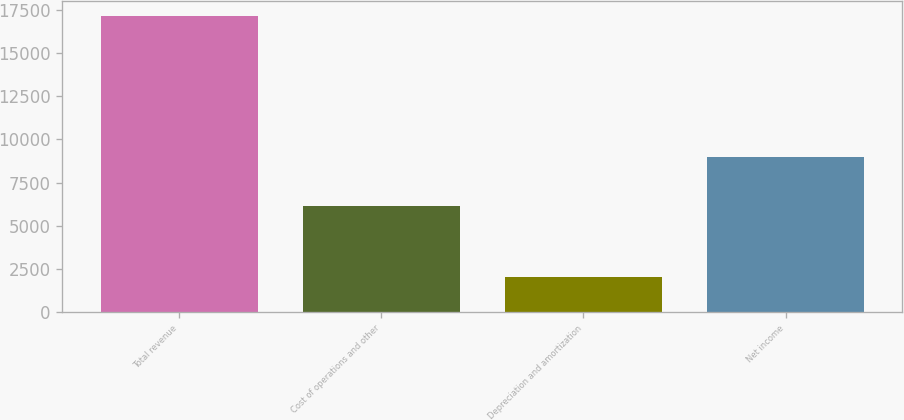<chart> <loc_0><loc_0><loc_500><loc_500><bar_chart><fcel>Total revenue<fcel>Cost of operations and other<fcel>Depreciation and amortization<fcel>Net income<nl><fcel>17154<fcel>6159<fcel>2023<fcel>8972<nl></chart> 